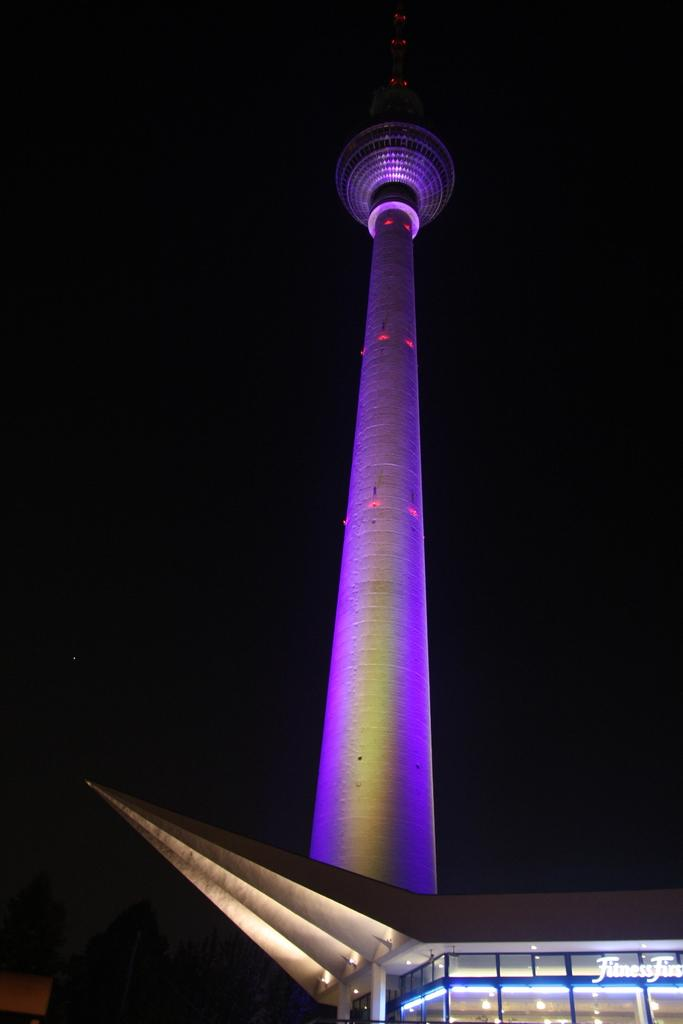What is the general color scheme of the image? The background of the image is dark. What structure can be seen in the image? There is a tower in the image. What other building is visible in the image? There appears to be a building on the right side of the image. What can be seen illuminating the image? Lights are visible in the image. Is there any additional information or marking on the image? There is a watermark in the image. What type of rhythm can be heard coming from the tower in the image? There is no sound or rhythm present in the image. 